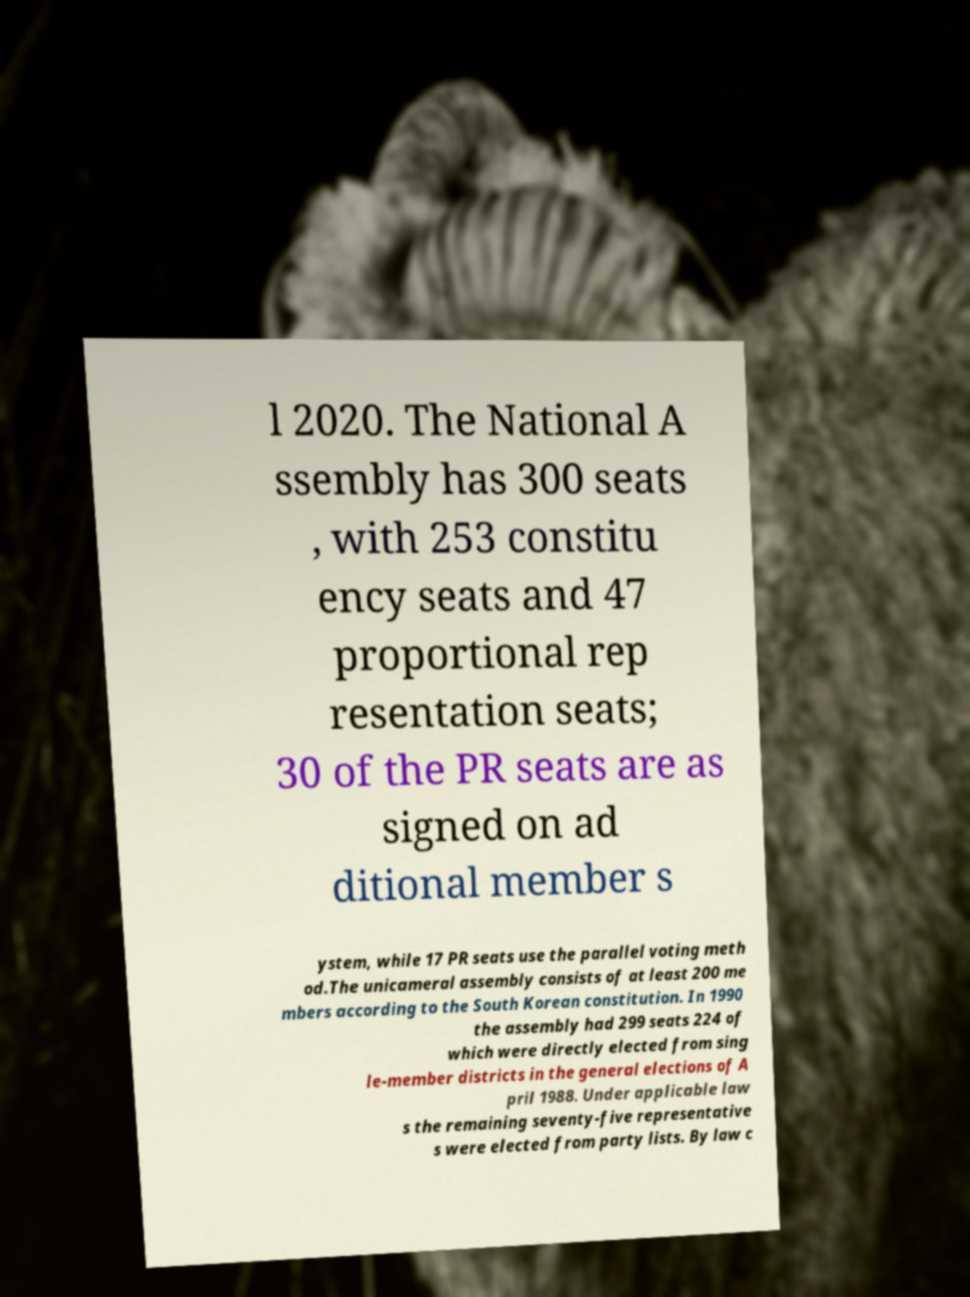Could you extract and type out the text from this image? l 2020. The National A ssembly has 300 seats , with 253 constitu ency seats and 47 proportional rep resentation seats; 30 of the PR seats are as signed on ad ditional member s ystem, while 17 PR seats use the parallel voting meth od.The unicameral assembly consists of at least 200 me mbers according to the South Korean constitution. In 1990 the assembly had 299 seats 224 of which were directly elected from sing le-member districts in the general elections of A pril 1988. Under applicable law s the remaining seventy-five representative s were elected from party lists. By law c 